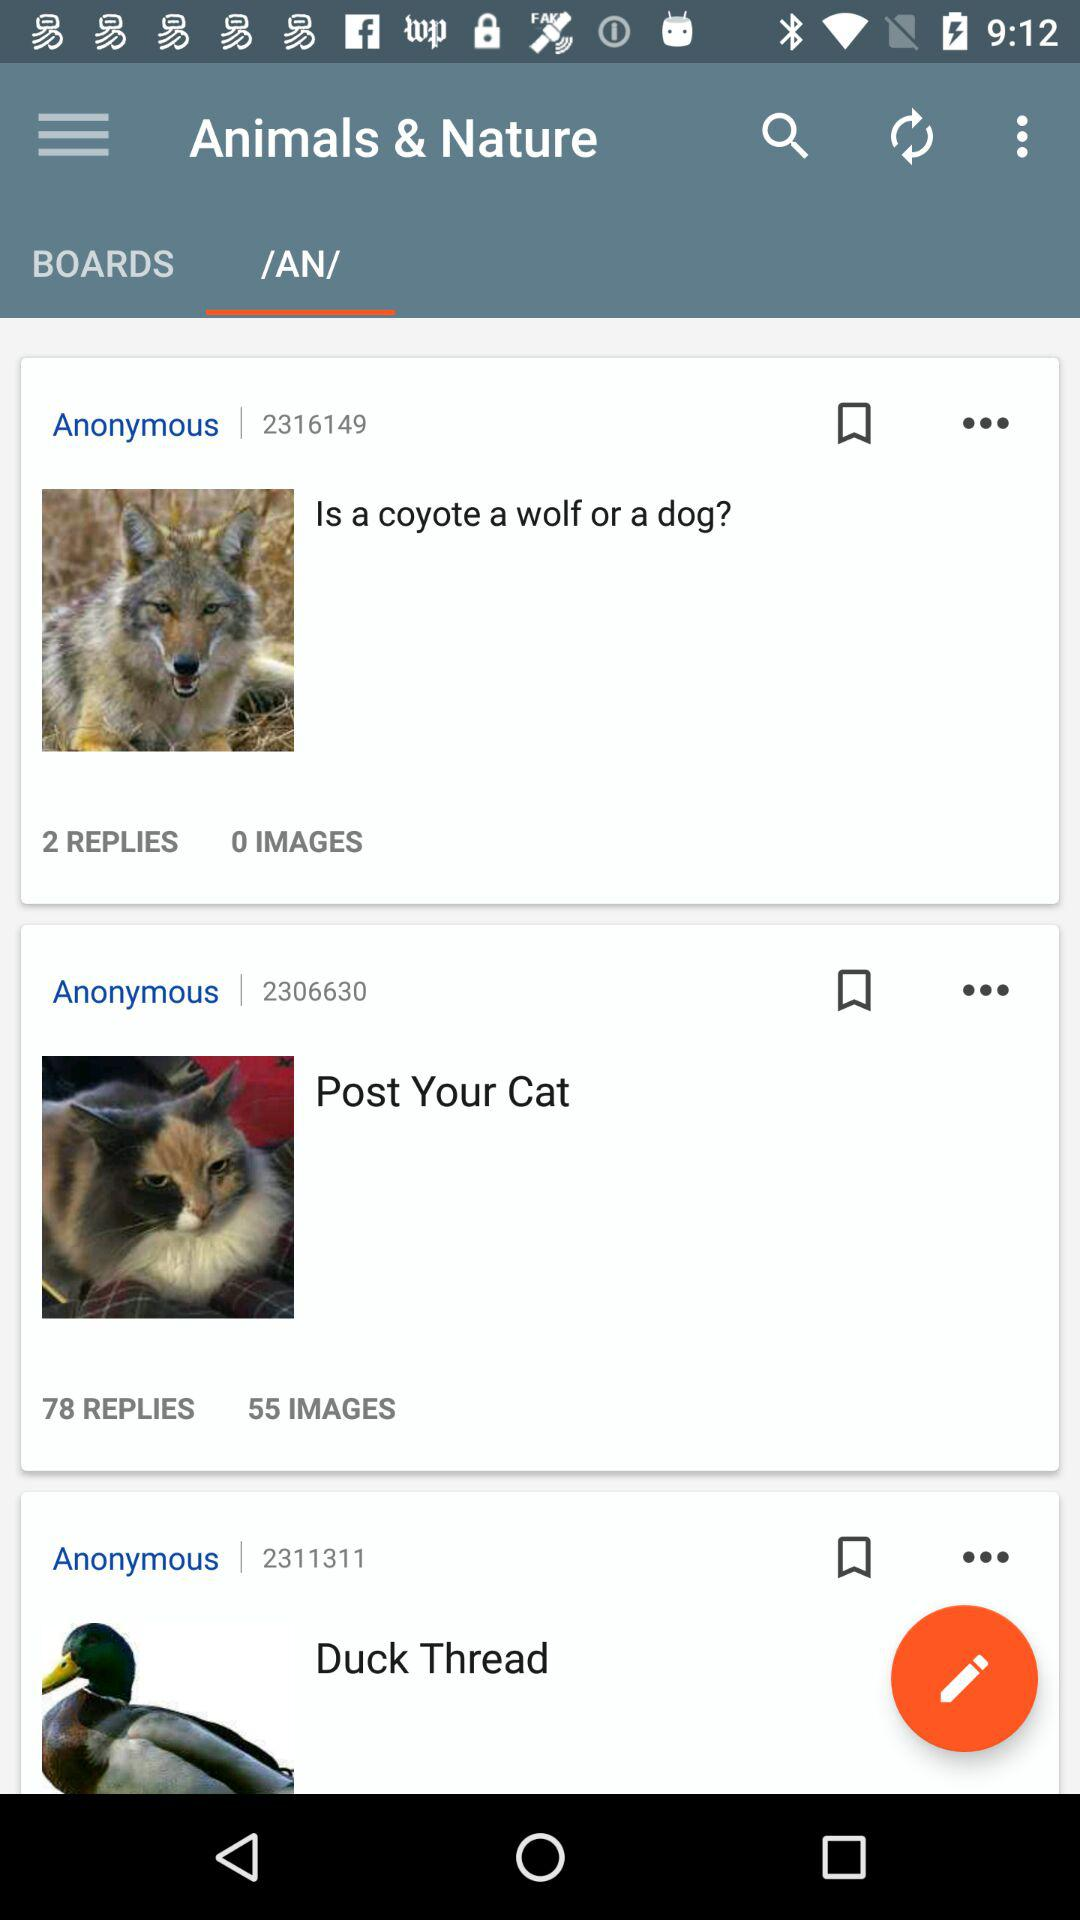What is the number of replies on the "Is a coyote a wolf or a dog" post? The number of replies is 2. 